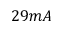Convert formula to latex. <formula><loc_0><loc_0><loc_500><loc_500>2 9 m A</formula> 